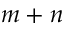Convert formula to latex. <formula><loc_0><loc_0><loc_500><loc_500>m + n</formula> 